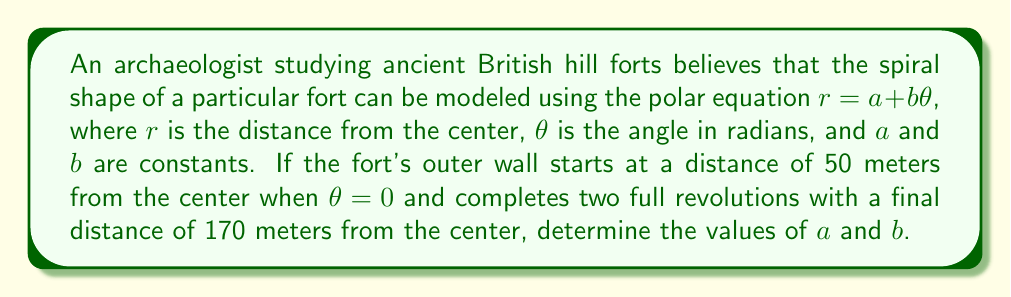Help me with this question. To solve this problem, we need to use the given information and the properties of the Archimedean spiral described by the equation $r = a + b\theta$.

1. We know that when $\theta = 0$, $r = 50$ meters. This gives us our first equation:
   $50 = a + b(0)$
   $50 = a$

2. After two full revolutions, $\theta = 4\pi$ radians, and $r = 170$ meters. This gives us our second equation:
   $170 = a + b(4\pi)$

3. Substituting $a = 50$ from step 1 into the equation from step 2:
   $170 = 50 + b(4\pi)$

4. Solve for $b$:
   $120 = b(4\pi)$
   $b = \frac{120}{4\pi} = \frac{30}{\pi}$

5. Therefore, the polar equation describing the spiral shape of the hill fort is:
   $r = 50 + \frac{30}{\pi}\theta$

To verify:
- When $\theta = 0$: $r = 50 + \frac{30}{\pi}(0) = 50$ meters
- When $\theta = 4\pi$: $r = 50 + \frac{30}{\pi}(4\pi) = 50 + 120 = 170$ meters

This matches the given information, confirming our solution.
Answer: $a = 50$, $b = \frac{30}{\pi}$ 